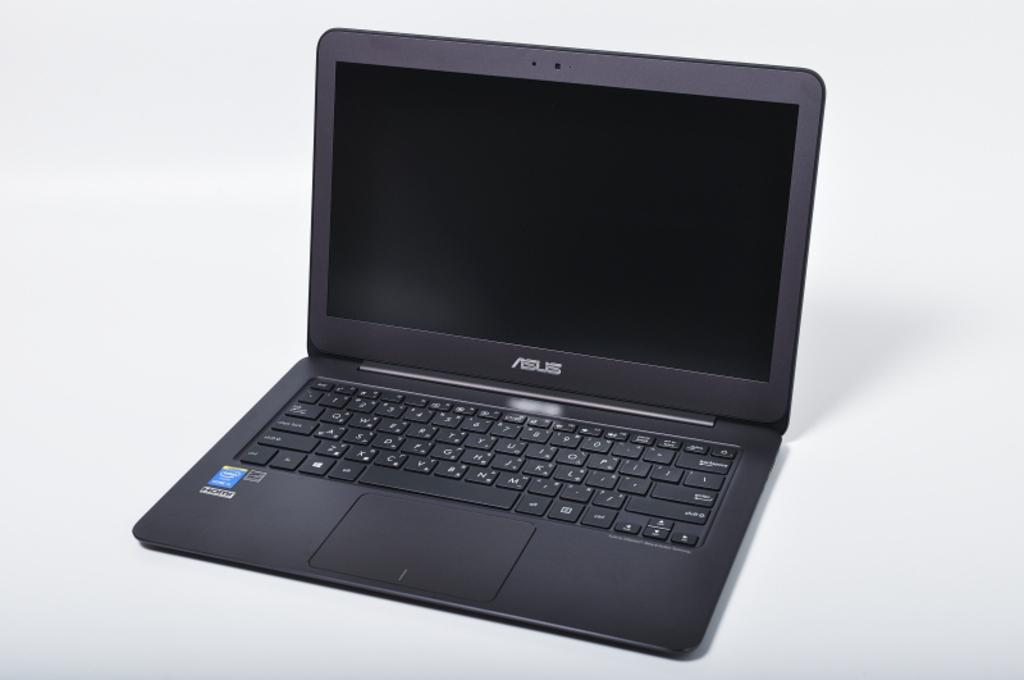Provide a one-sentence caption for the provided image. A black laptop with a keyboard that reads ASUS. 